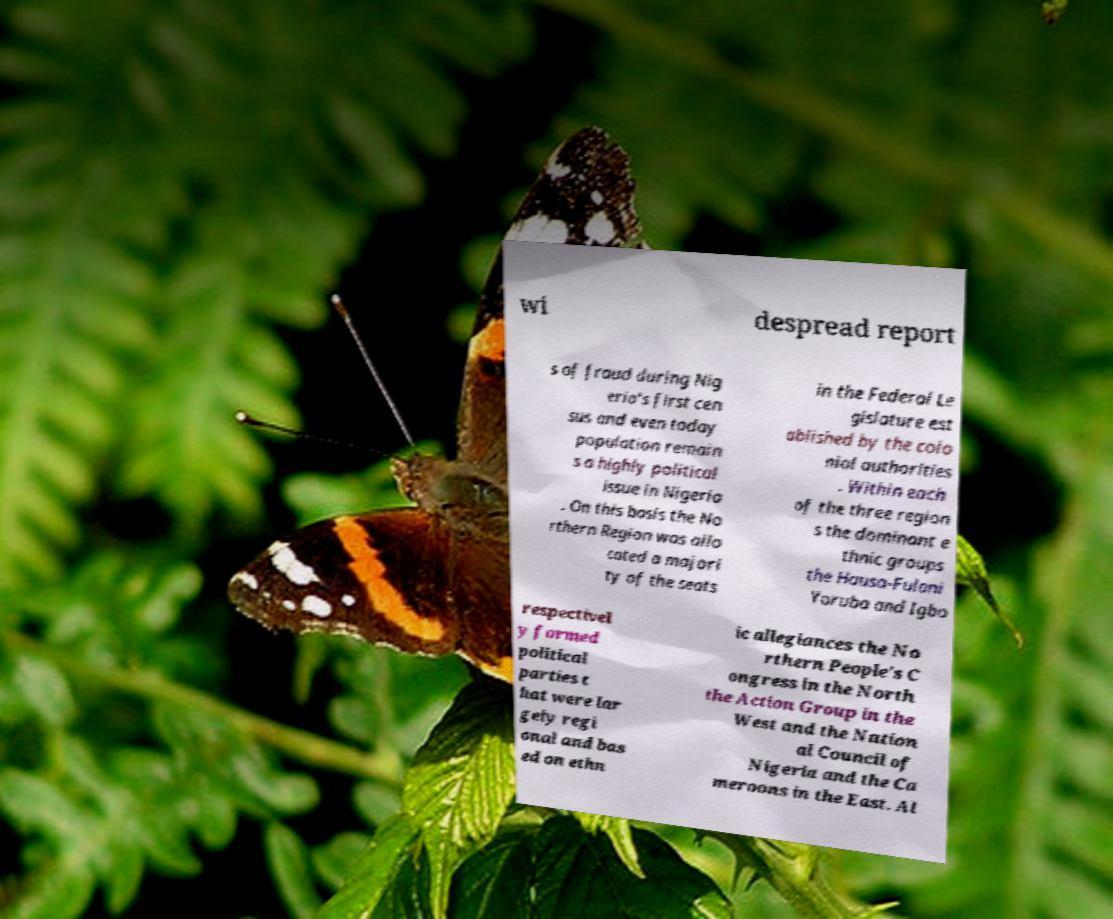There's text embedded in this image that I need extracted. Can you transcribe it verbatim? wi despread report s of fraud during Nig eria's first cen sus and even today population remain s a highly political issue in Nigeria . On this basis the No rthern Region was allo cated a majori ty of the seats in the Federal Le gislature est ablished by the colo nial authorities . Within each of the three region s the dominant e thnic groups the Hausa-Fulani Yoruba and Igbo respectivel y formed political parties t hat were lar gely regi onal and bas ed on ethn ic allegiances the No rthern People's C ongress in the North the Action Group in the West and the Nation al Council of Nigeria and the Ca meroons in the East. Al 